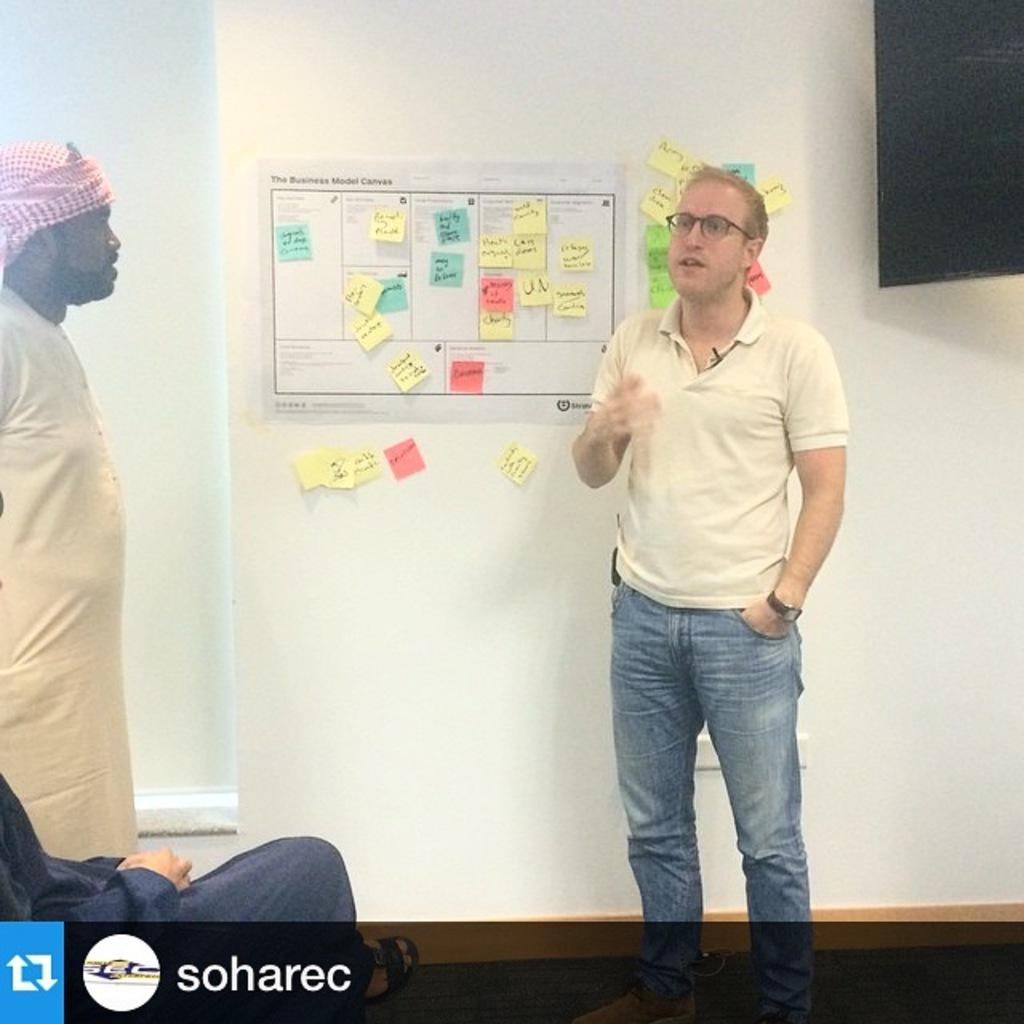Describe this image in one or two sentences. In this picture I can see there is a man standing here and he is wearing a cream t-shirt and there is a chart and there are some notes pasted on it. On to the left side I can see there is a man standing. 